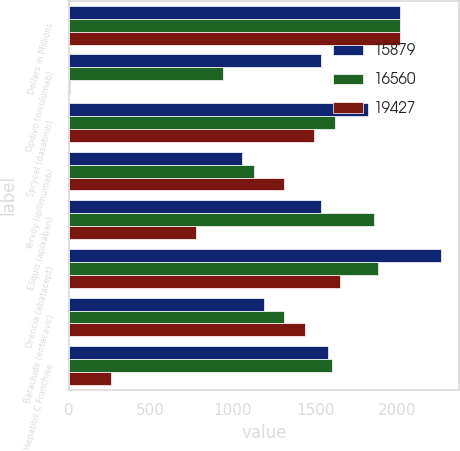<chart> <loc_0><loc_0><loc_500><loc_500><stacked_bar_chart><ecel><fcel>Dollars in Millions<fcel>Opdivo (nivolumab)<fcel>Sprycel (dasatinib)<fcel>Yervoy (ipilimumab)<fcel>Eliquis (apixaban)<fcel>Orencia (abatacept)<fcel>Baraclude (entecavir)<fcel>Hepatitis C Franchise<nl><fcel>15879<fcel>2016<fcel>1535.5<fcel>1824<fcel>1053<fcel>1535.5<fcel>2265<fcel>1192<fcel>1578<nl><fcel>16560<fcel>2015<fcel>942<fcel>1620<fcel>1126<fcel>1860<fcel>1885<fcel>1312<fcel>1603<nl><fcel>19427<fcel>2014<fcel>6<fcel>1493<fcel>1308<fcel>774<fcel>1652<fcel>1441<fcel>256<nl></chart> 